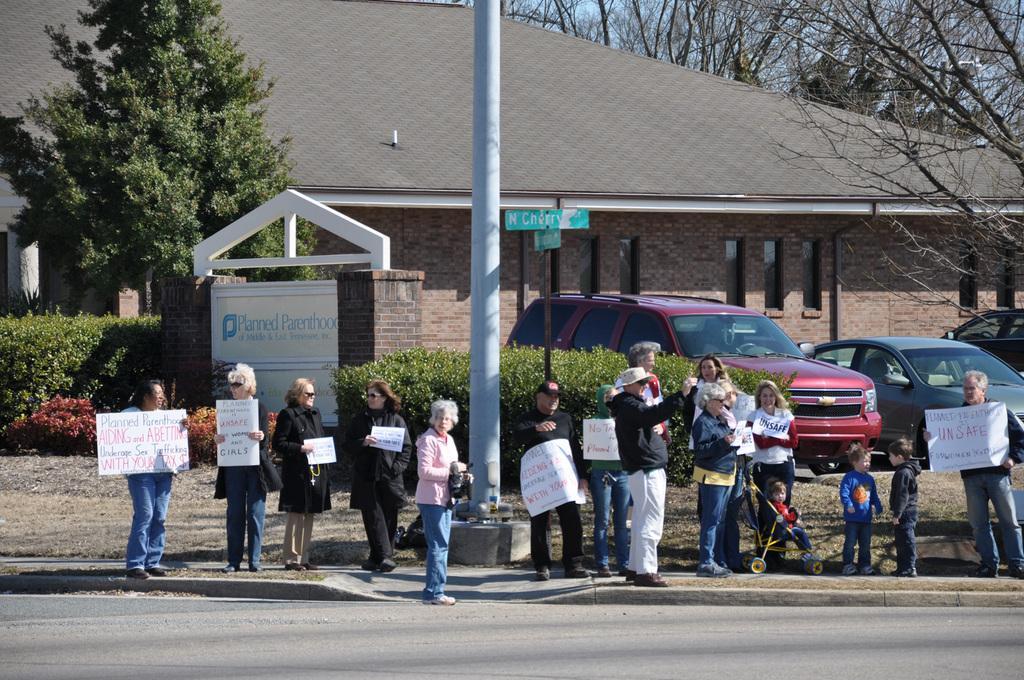Could you give a brief overview of what you see in this image? At the bottom of the picture, we see the road. Here, we see people are standing on the road and most of them are holding the charts or papers with some text written on it. In the middle of the picture, we see a pole. Behind that, we see shrubs and hedging plants. On the right side, we see trees and vehicles parked on the road. Beside that, we see a gate in white color with some text written on it. There are trees and a building in the background. 